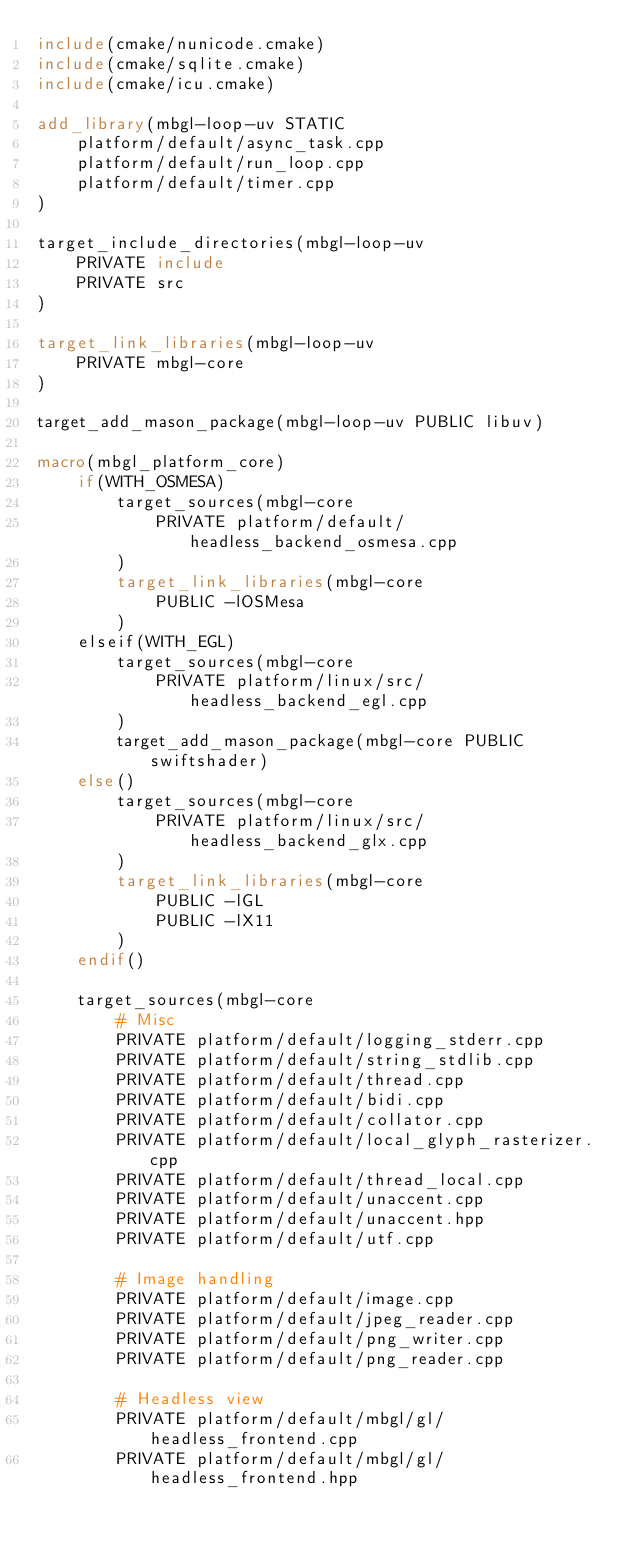<code> <loc_0><loc_0><loc_500><loc_500><_CMake_>include(cmake/nunicode.cmake)
include(cmake/sqlite.cmake)
include(cmake/icu.cmake)

add_library(mbgl-loop-uv STATIC
    platform/default/async_task.cpp
    platform/default/run_loop.cpp
    platform/default/timer.cpp
)

target_include_directories(mbgl-loop-uv
    PRIVATE include
    PRIVATE src
)

target_link_libraries(mbgl-loop-uv
    PRIVATE mbgl-core
)

target_add_mason_package(mbgl-loop-uv PUBLIC libuv)

macro(mbgl_platform_core)
    if(WITH_OSMESA)
        target_sources(mbgl-core
            PRIVATE platform/default/headless_backend_osmesa.cpp
        )
        target_link_libraries(mbgl-core
            PUBLIC -lOSMesa
        )
    elseif(WITH_EGL)
        target_sources(mbgl-core
            PRIVATE platform/linux/src/headless_backend_egl.cpp
        )
        target_add_mason_package(mbgl-core PUBLIC swiftshader)
    else()
        target_sources(mbgl-core
            PRIVATE platform/linux/src/headless_backend_glx.cpp
        )
        target_link_libraries(mbgl-core
            PUBLIC -lGL
            PUBLIC -lX11
        )
    endif()

    target_sources(mbgl-core
        # Misc
        PRIVATE platform/default/logging_stderr.cpp
        PRIVATE platform/default/string_stdlib.cpp
        PRIVATE platform/default/thread.cpp
        PRIVATE platform/default/bidi.cpp
        PRIVATE platform/default/collator.cpp
        PRIVATE platform/default/local_glyph_rasterizer.cpp
        PRIVATE platform/default/thread_local.cpp
        PRIVATE platform/default/unaccent.cpp
        PRIVATE platform/default/unaccent.hpp
        PRIVATE platform/default/utf.cpp

        # Image handling
        PRIVATE platform/default/image.cpp
        PRIVATE platform/default/jpeg_reader.cpp
        PRIVATE platform/default/png_writer.cpp
        PRIVATE platform/default/png_reader.cpp

        # Headless view
        PRIVATE platform/default/mbgl/gl/headless_frontend.cpp
        PRIVATE platform/default/mbgl/gl/headless_frontend.hpp</code> 